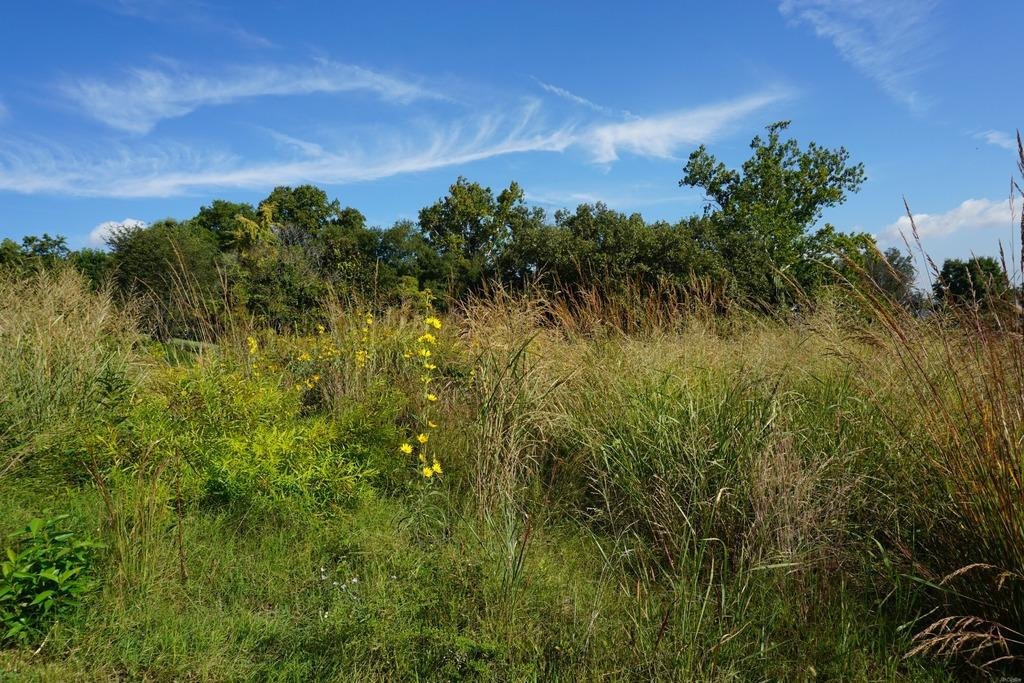What type of natural environment is depicted in the image? The image contains a forest view. What type of vegetation can be seen at the bottom of the image? There is grass visible at the front bottom side of the image. What other types of vegetation are present in the image? Trees are visible in the image. What is the condition of the sky in the image? The sky is clear and blue in the image. What type of scent can be detected from the fire in the image? There is no fire present in the image, so no scent can be detected. 